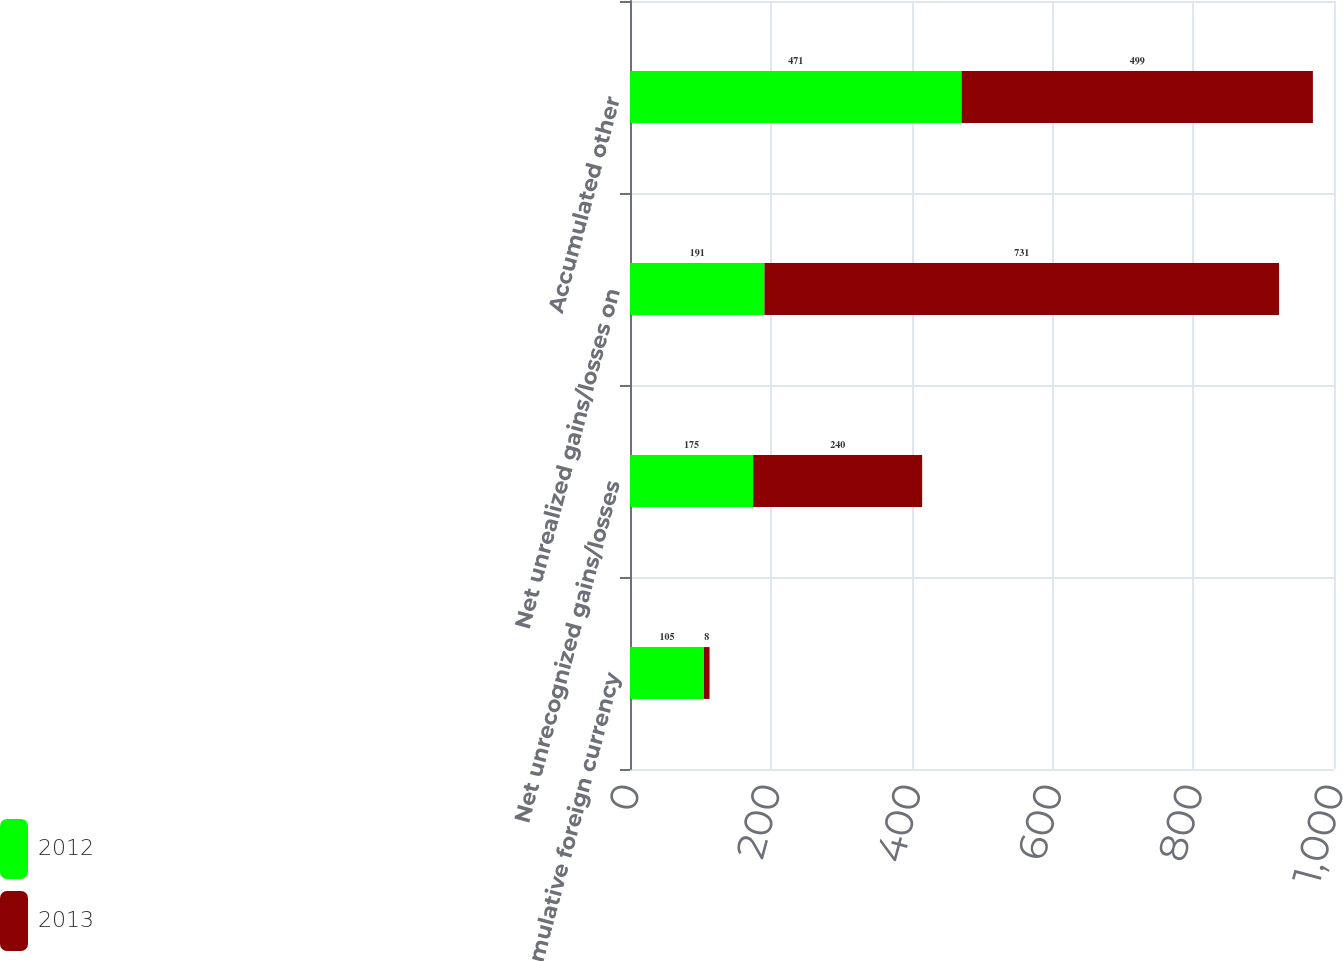Convert chart. <chart><loc_0><loc_0><loc_500><loc_500><stacked_bar_chart><ecel><fcel>Cumulative foreign currency<fcel>Net unrecognized gains/losses<fcel>Net unrealized gains/losses on<fcel>Accumulated other<nl><fcel>2012<fcel>105<fcel>175<fcel>191<fcel>471<nl><fcel>2013<fcel>8<fcel>240<fcel>731<fcel>499<nl></chart> 